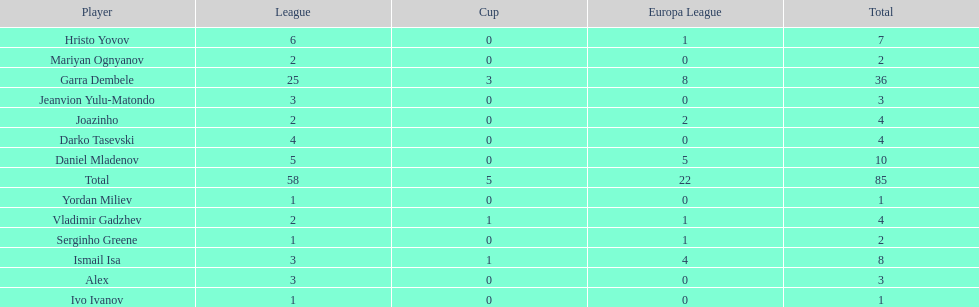Who was the top goalscorer on this team? Garra Dembele. 